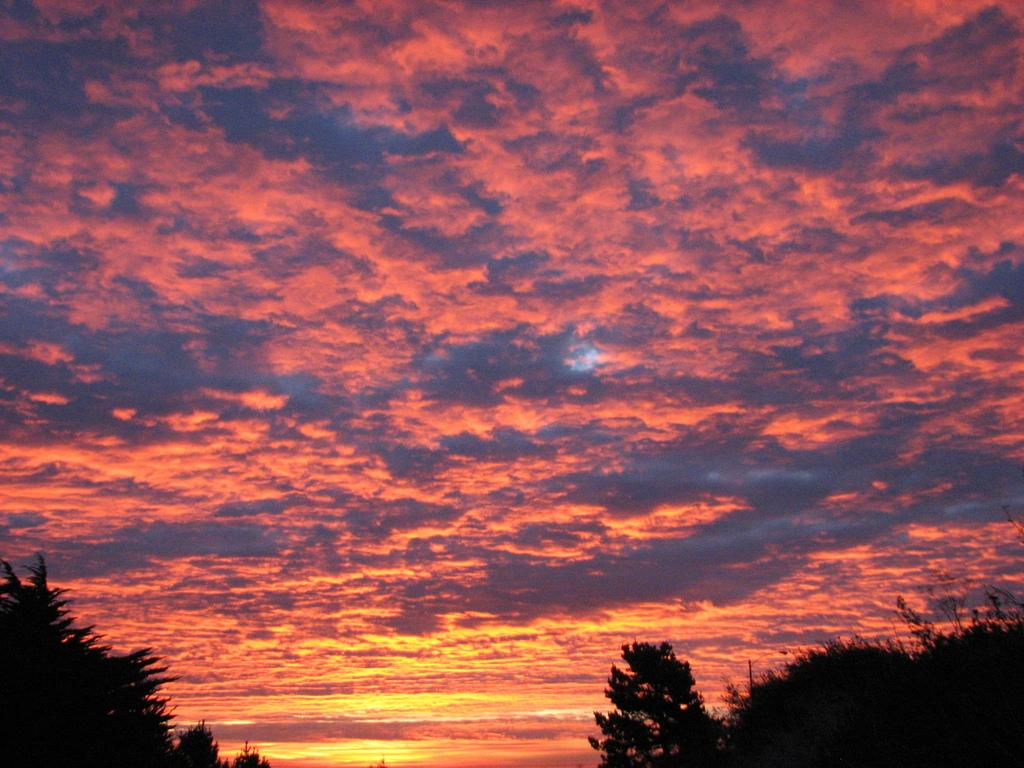What can be seen at the top of the image? The sky is visible in the image. What is present in the sky? Clouds are present in the sky. What type of vegetation can be seen in the image? There are trees in the image. What type of agreement is being signed by the yam in the image? There is no yam present in the image, and therefore no agreement can be signed. 